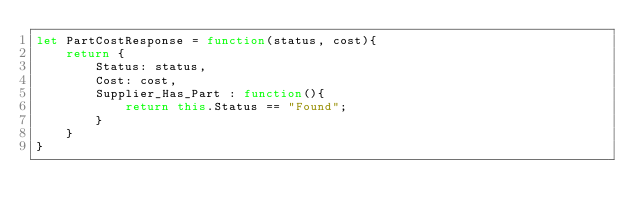<code> <loc_0><loc_0><loc_500><loc_500><_JavaScript_>let PartCostResponse = function(status, cost){
    return {
        Status: status,
        Cost: cost,
        Supplier_Has_Part : function(){
            return this.Status == "Found";
        }
    }
}</code> 